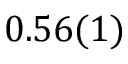Convert formula to latex. <formula><loc_0><loc_0><loc_500><loc_500>0 . 5 6 ( 1 )</formula> 